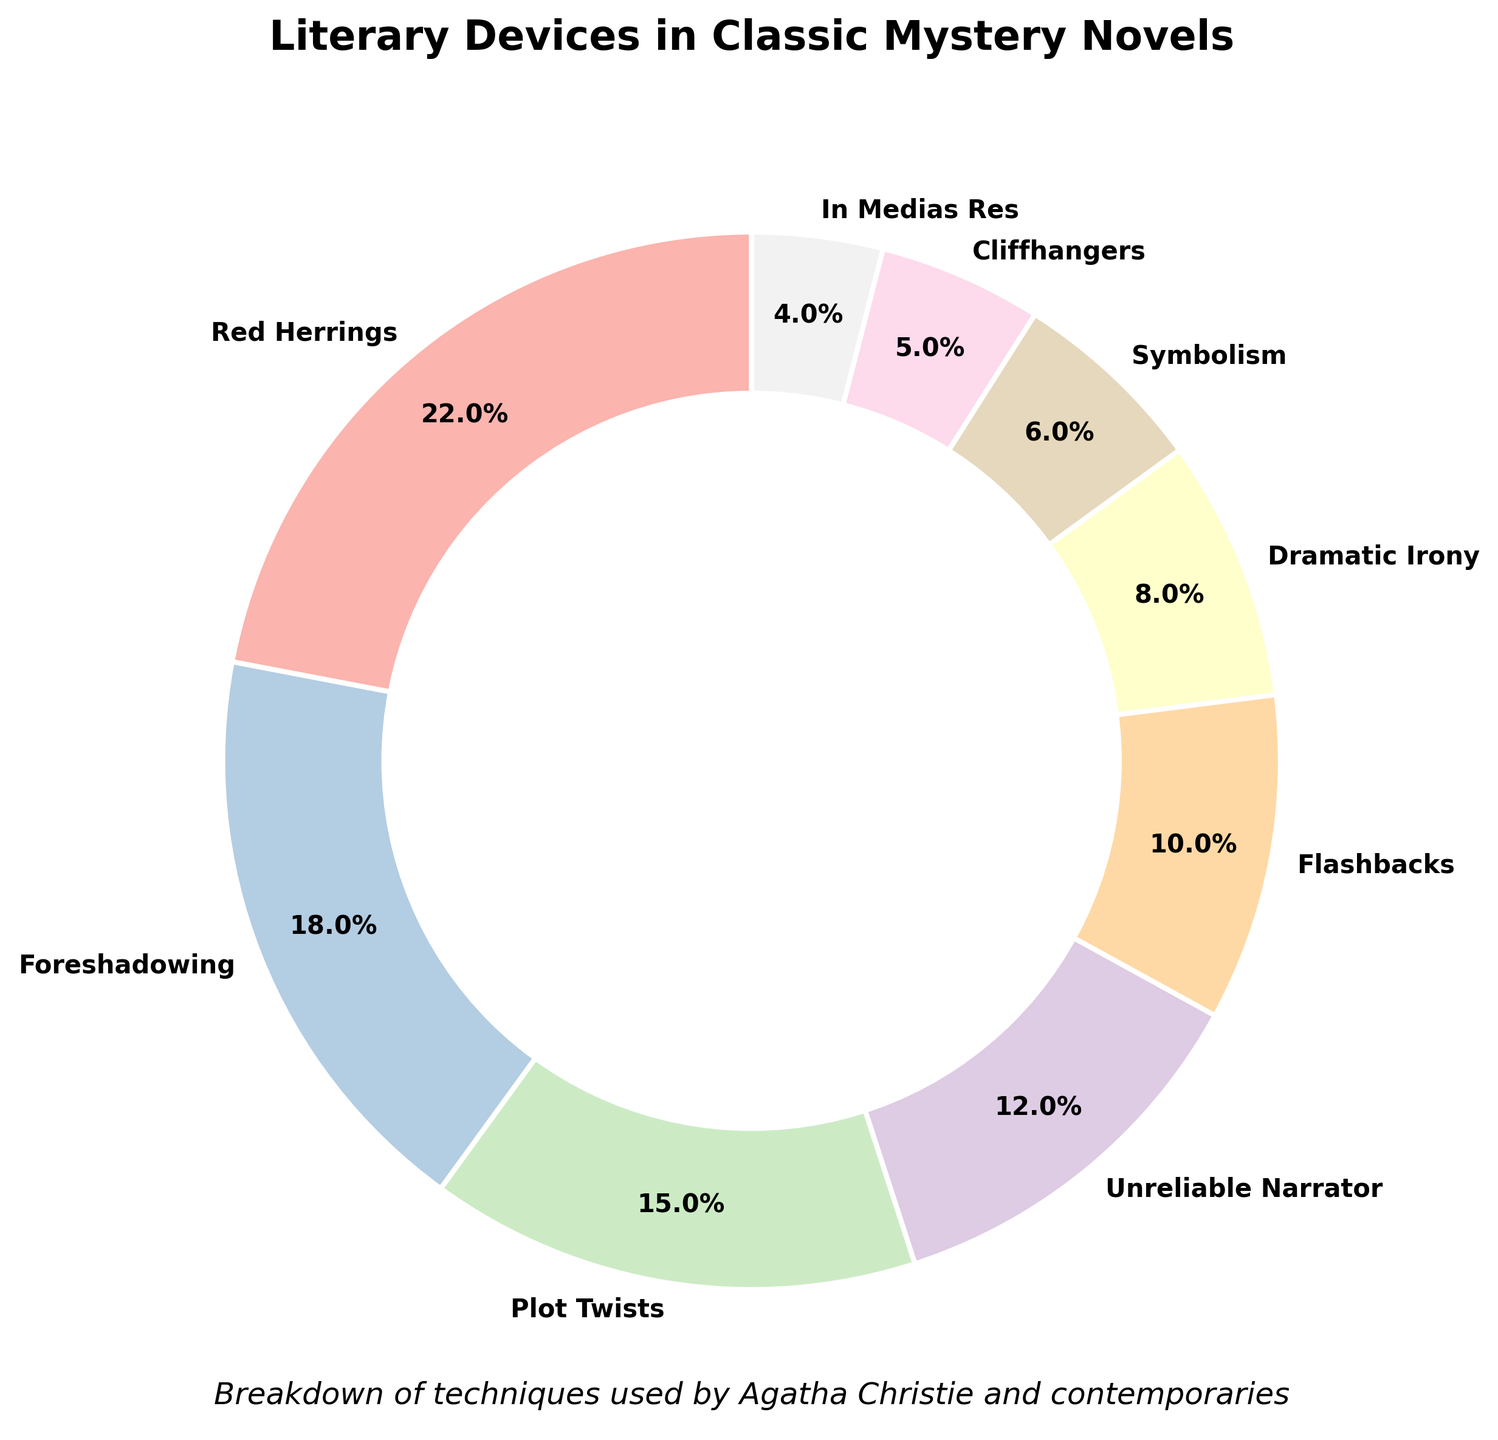What is the most frequently used literary device in classic mystery novels according to the pie chart? The pie chart shows different percentages for each literary device. The largest slice corresponds to "Red Herrings" with 22%.
Answer: Red Herrings Which is more prevalent, foreshadowing or plot twists, and by how much? The pie chart shows foreshadowing at 18% and plot twists at 15%. Subtract 15% from 18% to find the difference.
Answer: Foreshadowing by 3% What is the combined percentage of plot twists and unreliable narrator? The pie chart indicates 15% for plot twists and 12% for unreliable narrator. Adding these together gives 15% + 12%.
Answer: 27% Are flashbacks used more frequently than symbolism? Looking at the pie chart, flashbacks are at 10% and symbolism is at 6%. Comparing these values shows that flashbacks are indeed used more frequently.
Answer: Yes What is the least frequently used literary device shown in the pie chart? The pie chart shows "In Medias Res" with the smallest percentage of 4%.
Answer: In Medias Res Of "Dramatic Irony" and "Cliffhangers," which has a lower percentage and what is the difference between them? The percentage for dramatic irony is 8% and cliffhangers is 5% according to the pie chart. Subtracting 5% from 8% gives the difference.
Answer: Cliffhangers by 3% What is the total percentage of the three least frequently used literary devices? The three least frequently used devices are "In Medias Res" at 4%, "Cliffhangers" at 5%, and "Symbolism" at 6%. Add these percentages together: 4% + 5% + 6%.
Answer: 15% Which literary device is represented by a color near the middle of the color palette in the pie chart? The colors in the pie chart use a Pastel1 palette with several shades. The device near the middle shade would be "Plot Twists," which falls around the middle of the pie chart color continuum.
Answer: Plot Twists How does the percentage for unreliable narrator compare to that for foreshadowing? Unreliable narrator is at 12% and foreshadowing is at 18% according to the pie chart. Comparing these, unreliable narrator is less by 6%.
Answer: Less by 6% What is the sum of the percentages for the top four literary devices? The top four literary devices are Red Herrings (22%), Foreshadowing (18%), Plot Twists (15%), and Unreliable Narrator (12%). Add these together: 22% + 18% + 15% + 12%.
Answer: 67% 